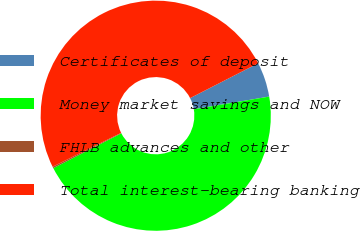Convert chart to OTSL. <chart><loc_0><loc_0><loc_500><loc_500><pie_chart><fcel>Certificates of deposit<fcel>Money market savings and NOW<fcel>FHLB advances and other<fcel>Total interest-bearing banking<nl><fcel>4.87%<fcel>45.13%<fcel>0.21%<fcel>49.79%<nl></chart> 